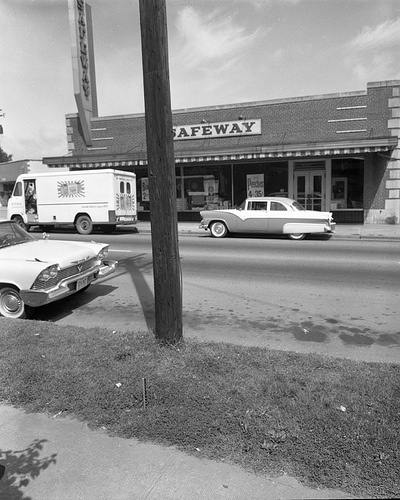Describe the objects in this image and their specific colors. I can see truck in silver, white, darkgray, gray, and black tones, car in silver, white, gray, darkgray, and black tones, and car in silver, white, darkgray, gray, and black tones in this image. 